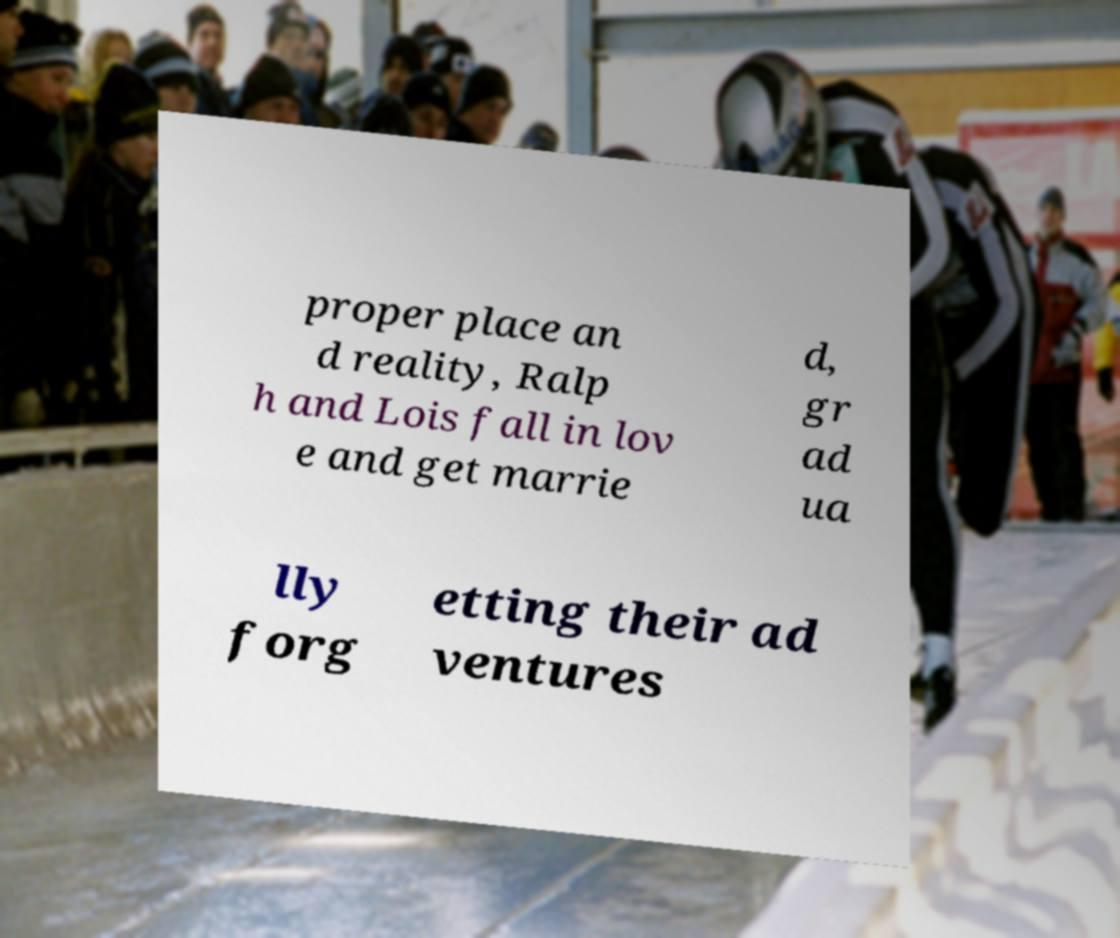Please read and relay the text visible in this image. What does it say? proper place an d reality, Ralp h and Lois fall in lov e and get marrie d, gr ad ua lly forg etting their ad ventures 